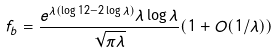<formula> <loc_0><loc_0><loc_500><loc_500>f _ { b } = \frac { e ^ { \lambda ( \log { 1 2 } - 2 \log { \lambda } ) } \lambda \log { \lambda } } { \sqrt { \pi \lambda } } ( 1 + O ( 1 / \lambda ) )</formula> 